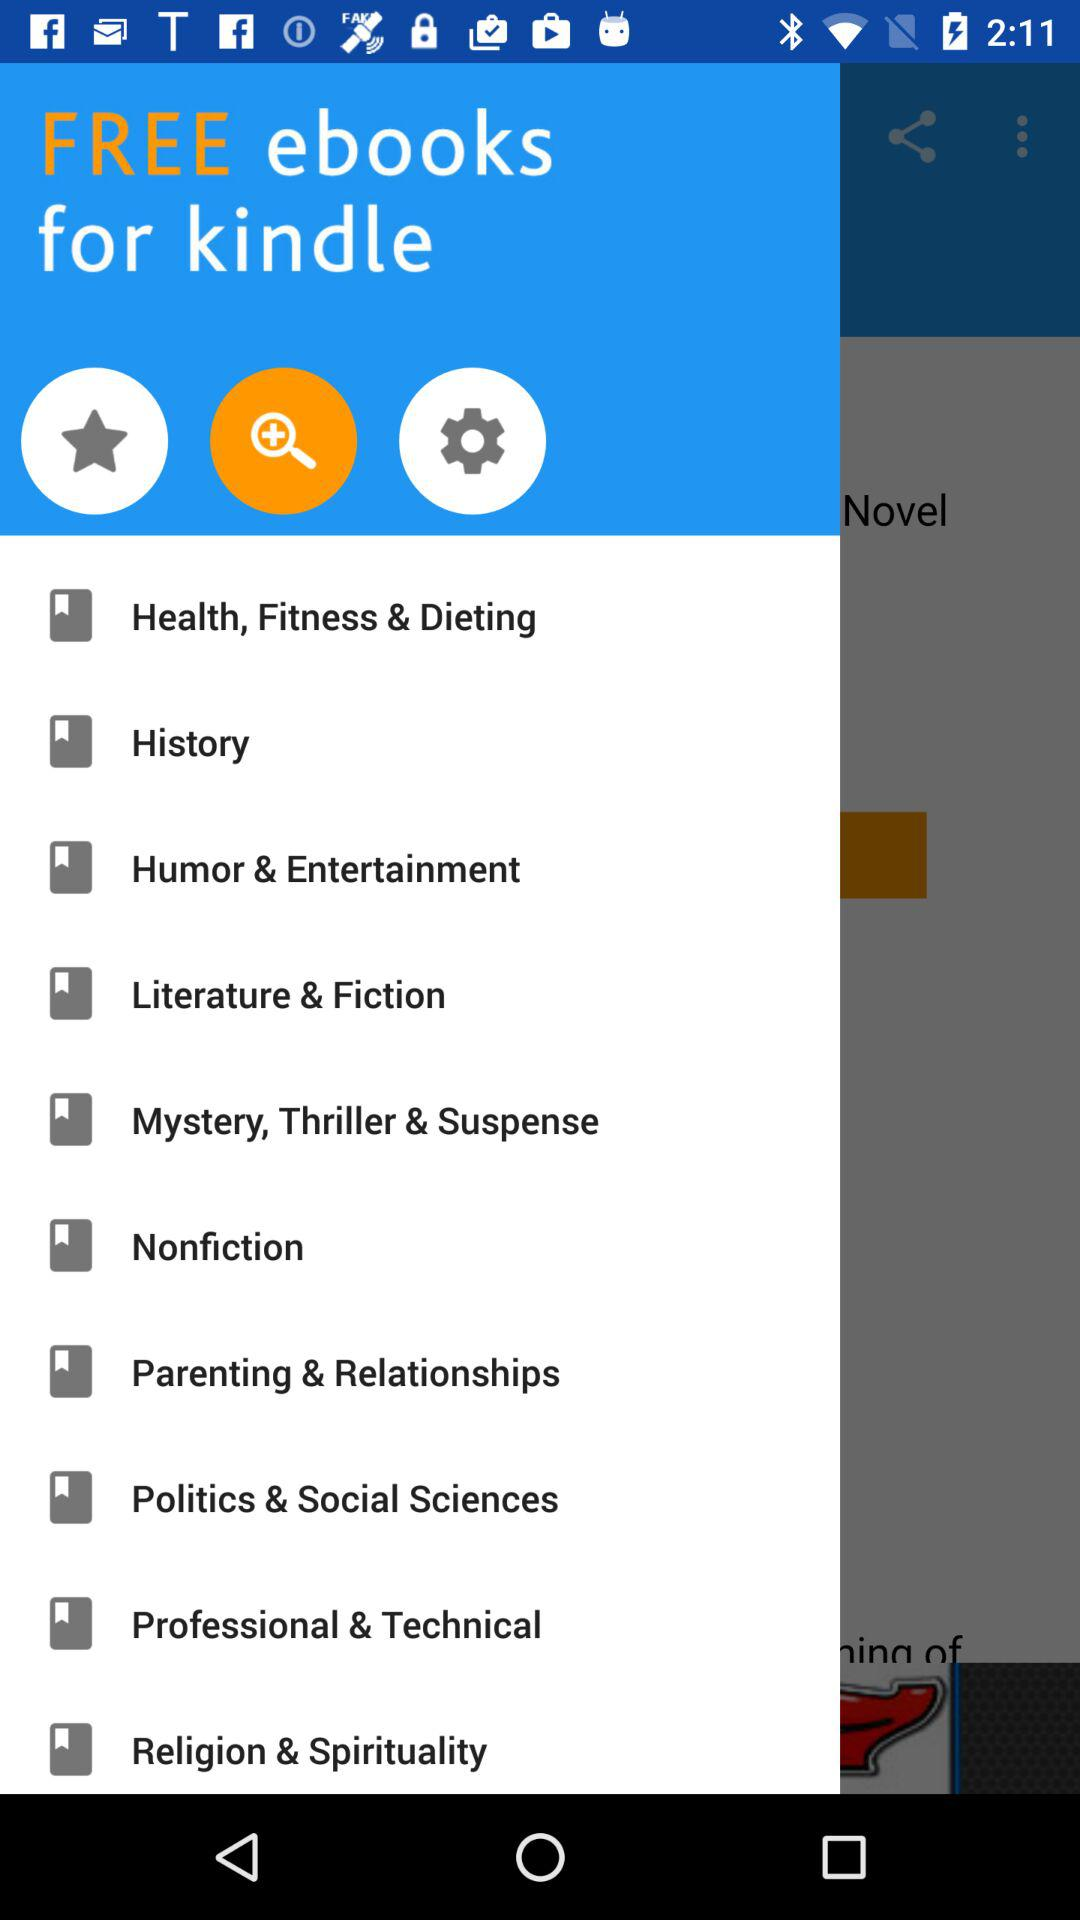What ebooks are free for "kindle"? The free ebooks for kindle are " Health, Fitness & Dieting", "History", "Humour & Entertainment", "Literature & Fiction", "Mystery, Thriller & Suspense", "Nonfiction", "Parenting & Relationships", "Politics & Social Sciences", "Professional & Technical" and "Religion & Spirituality". 